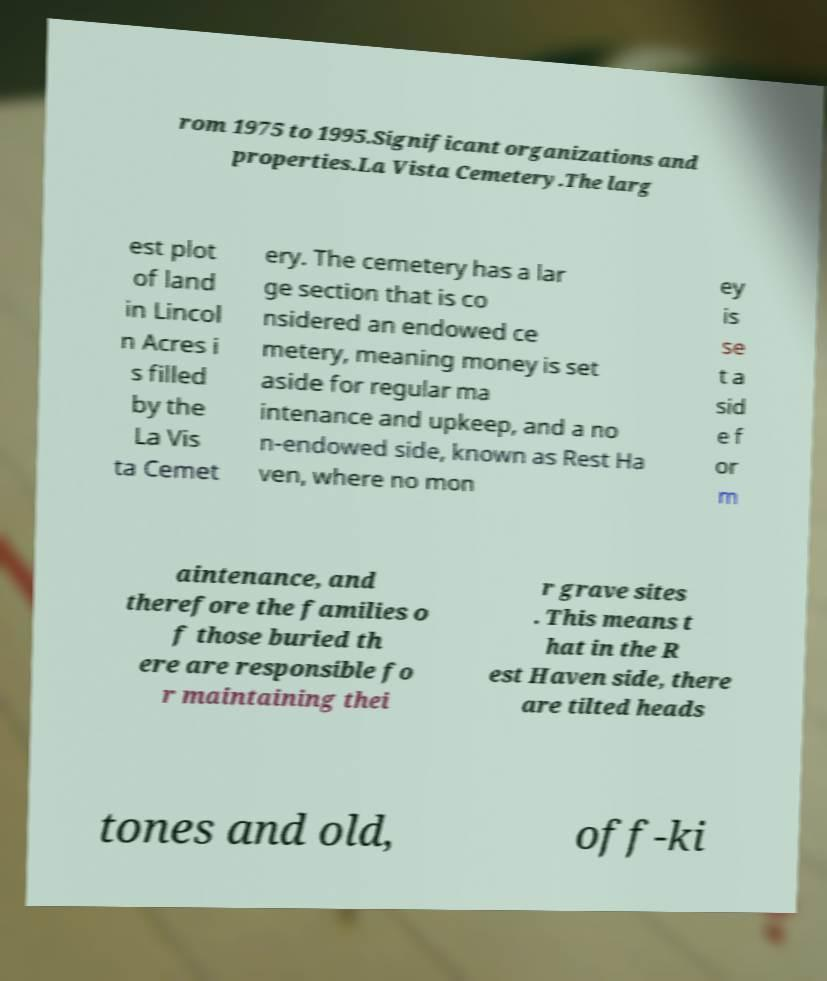Could you extract and type out the text from this image? rom 1975 to 1995.Significant organizations and properties.La Vista Cemetery.The larg est plot of land in Lincol n Acres i s filled by the La Vis ta Cemet ery. The cemetery has a lar ge section that is co nsidered an endowed ce metery, meaning money is set aside for regular ma intenance and upkeep, and a no n-endowed side, known as Rest Ha ven, where no mon ey is se t a sid e f or m aintenance, and therefore the families o f those buried th ere are responsible fo r maintaining thei r grave sites . This means t hat in the R est Haven side, there are tilted heads tones and old, off-ki 